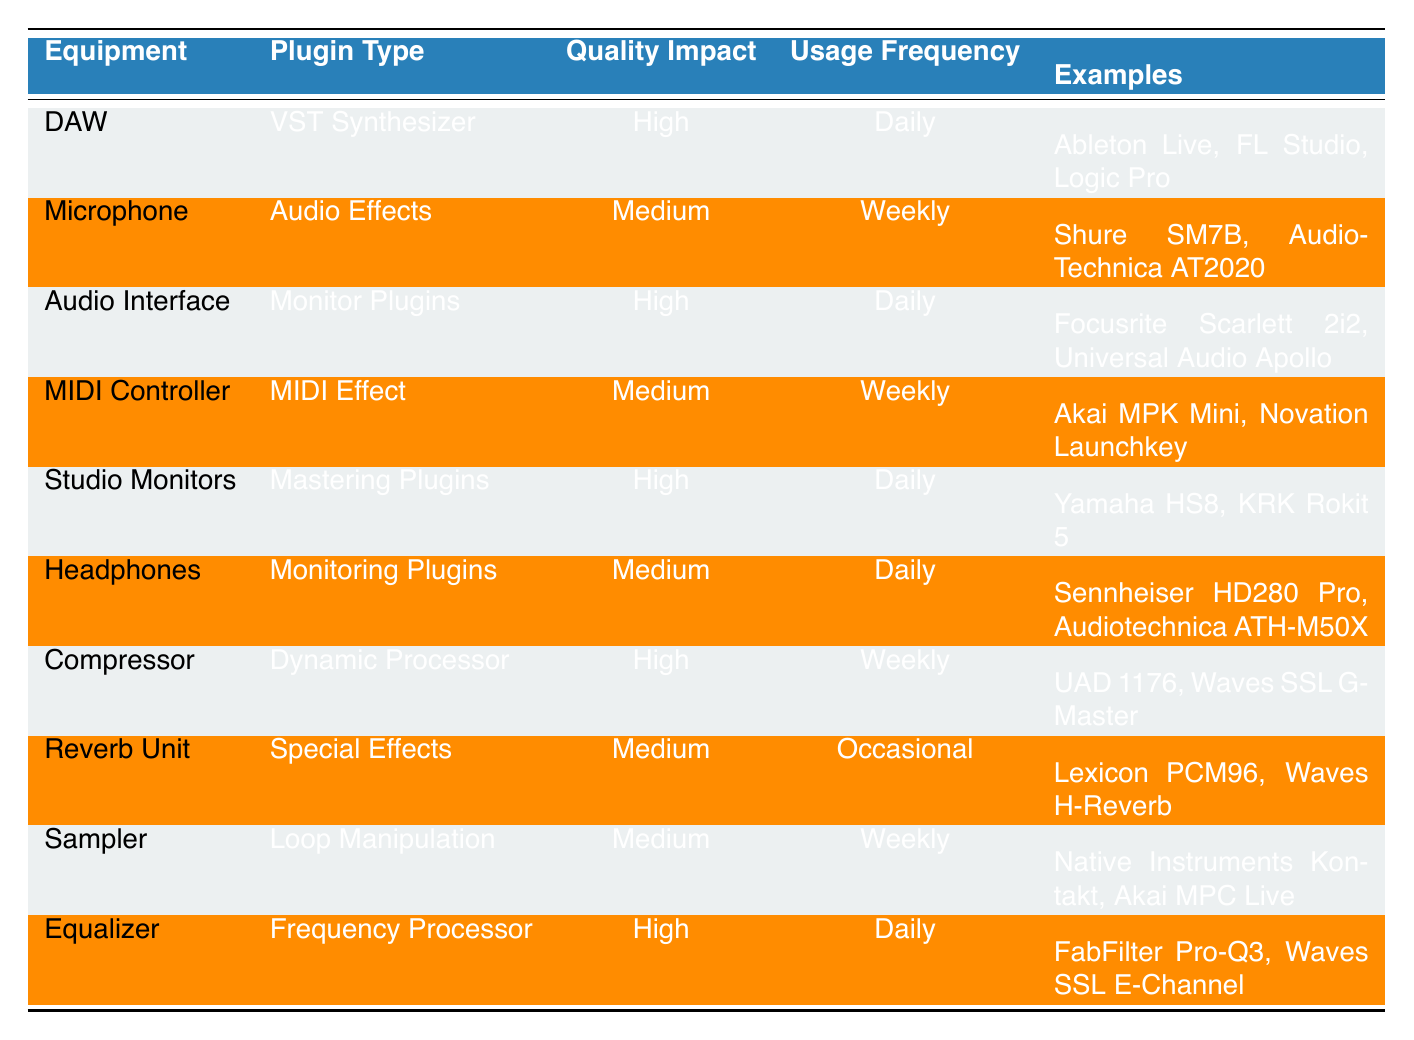What is the quality impact of using a DAW? The table indicates that the quality impact associated with using a DAW (Digital Audio Workstation) is classified as "High."
Answer: High How often is a Microphone used in music production? According to the table, a microphone is used weekly in music production.
Answer: Weekly Which equipment has the highest quality impact and is used daily? The DAW, Audio Interface, Studio Monitors, and Equalizer all have a high quality impact and are used daily, as stated in the table.
Answer: DAW, Audio Interface, Studio Monitors, Equalizer Is a Reverb Unit used frequently? The usage frequency for a Reverb Unit is listed as "Occasional," meaning it is not used frequently.
Answer: No How many types of equipment have a medium quality impact and are used daily? The table shows that only the Headphones have a medium quality impact and are used daily. Thus, there is one type of equipment.
Answer: 1 What can you infer about the frequency of Compressor usage? The table states that the Compressor is used weekly, which suggests it is less frequently used compared to daily equipment but more than occasional use.
Answer: Weekly Which equipment types are used daily and classified as high quality impact? The equipment that is used daily and classified as high quality impact includes DAW, Audio Interface, Studio Monitors, and Equalizer, as per the table.
Answer: DAW, Audio Interface, Studio Monitors, Equalizer Are all the equipment examples known for high quality impact used daily? The examples show that not all high quality impact equipment is used daily, as the Compressor, which has a high impact, is used weekly.
Answer: No What is the average frequency of use for equipment with medium quality impact? The equipment with medium quality impact has usage frequencies of "Weekly" (Microphone, MIDI Controller, Sampler) and "Daily" (Headphones), and "Occasional" (Reverb Unit). To find the average, we can assign Daily=1, Weekly=2, and Occasional=3. Thus, the average is (1 + 2 + 2 + 3) / 4 = 2, translating back to "Weekly."
Answer: Weekly 